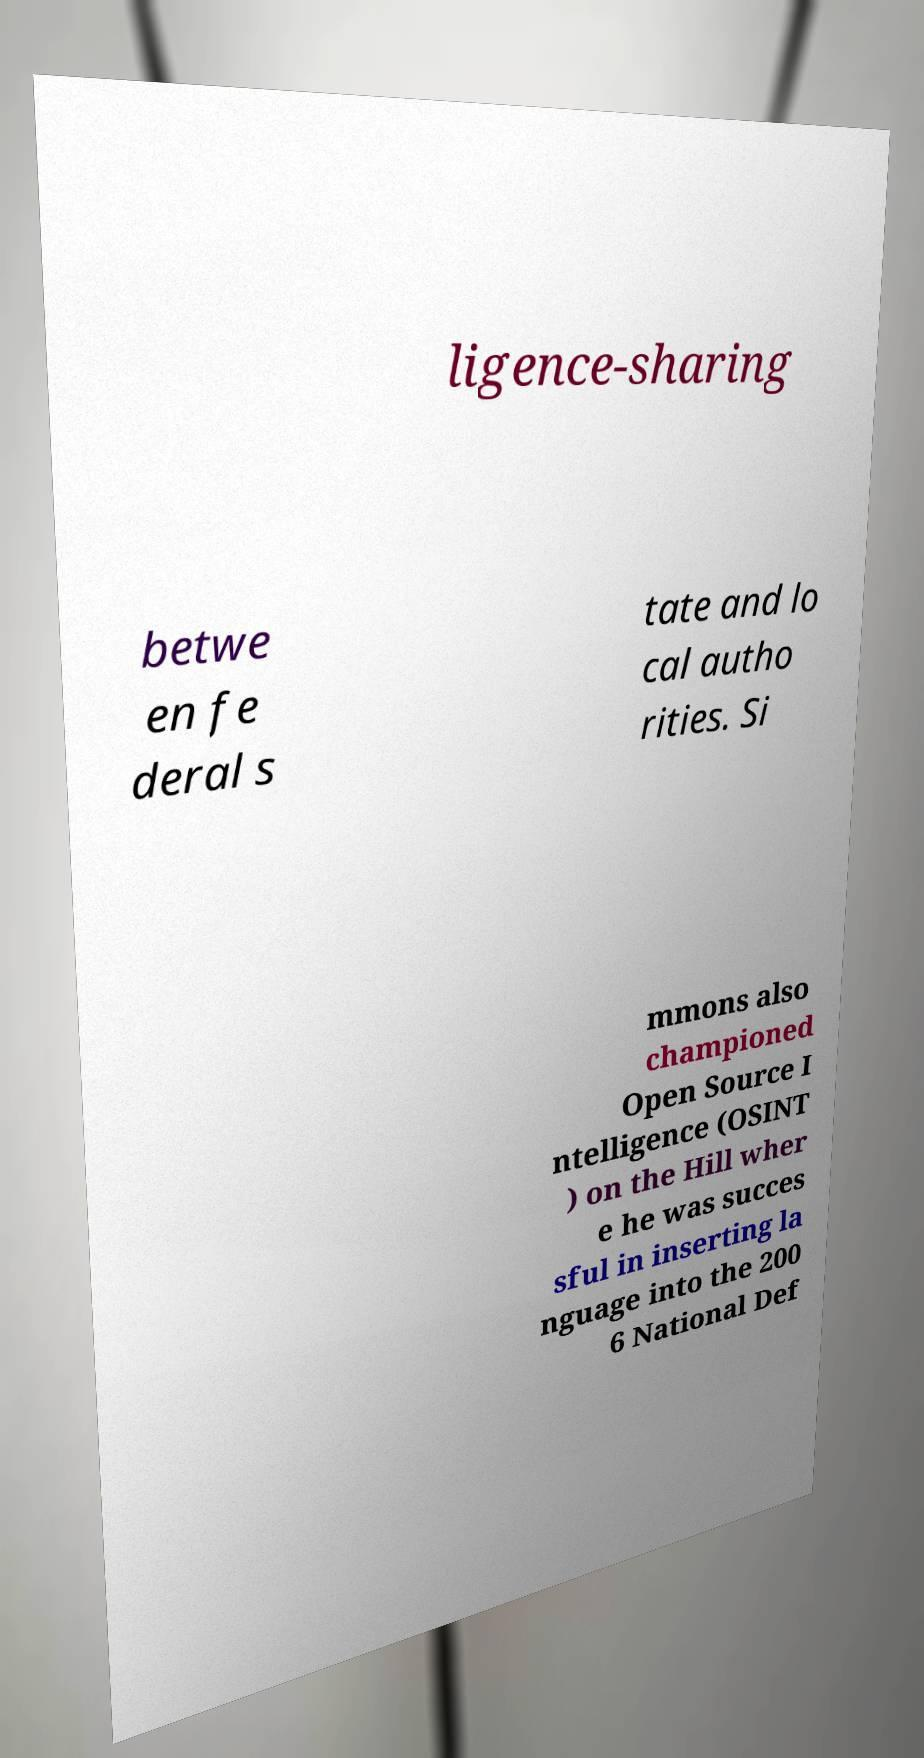I need the written content from this picture converted into text. Can you do that? ligence-sharing betwe en fe deral s tate and lo cal autho rities. Si mmons also championed Open Source I ntelligence (OSINT ) on the Hill wher e he was succes sful in inserting la nguage into the 200 6 National Def 